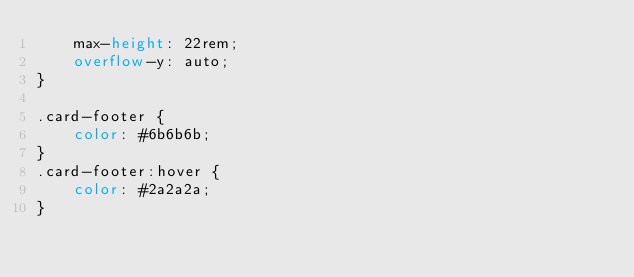Convert code to text. <code><loc_0><loc_0><loc_500><loc_500><_CSS_>    max-height: 22rem;
    overflow-y: auto;
}

.card-footer {
    color: #6b6b6b;
}
.card-footer:hover {
    color: #2a2a2a;
}
</code> 